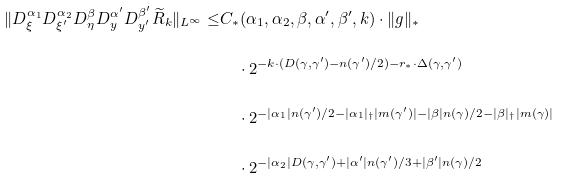<formula> <loc_0><loc_0><loc_500><loc_500>\| D ^ { \alpha _ { 1 } } _ { \xi } D ^ { \alpha _ { 2 } } _ { \xi ^ { \prime } } D ^ { \beta } _ { \eta } D ^ { \alpha ^ { \prime } } _ { y } D ^ { \beta ^ { \prime } } _ { y ^ { \prime } } \widetilde { R } _ { k } \| _ { L ^ { \infty } } \leq & C _ { * } ( \alpha _ { 1 } , \alpha _ { 2 } , \beta , \alpha ^ { \prime } , \beta ^ { \prime } , k ) \cdot \| g \| _ { * } \\ & \quad \cdot 2 ^ { - k \cdot ( D ( \gamma , \gamma ^ { \prime } ) - n ( \gamma ^ { \prime } ) / 2 ) - r _ { * } \cdot \Delta ( \gamma , \gamma ^ { \prime } ) } \\ & \quad \cdot 2 ^ { - | \alpha _ { 1 } | n ( \gamma ^ { \prime } ) / 2 - | \alpha _ { 1 } | _ { \dag } | m ( \gamma ^ { \prime } ) | - | \beta | n ( \gamma ) / 2 - | \beta | _ { \dag } | m ( \gamma ) | } \\ & \quad \cdot 2 ^ { - | \alpha _ { 2 } | D ( \gamma , \gamma ^ { \prime } ) + | \alpha ^ { \prime } | n ( \gamma ^ { \prime } ) / 3 + | \beta ^ { \prime } | n ( \gamma ) / 2 }</formula> 